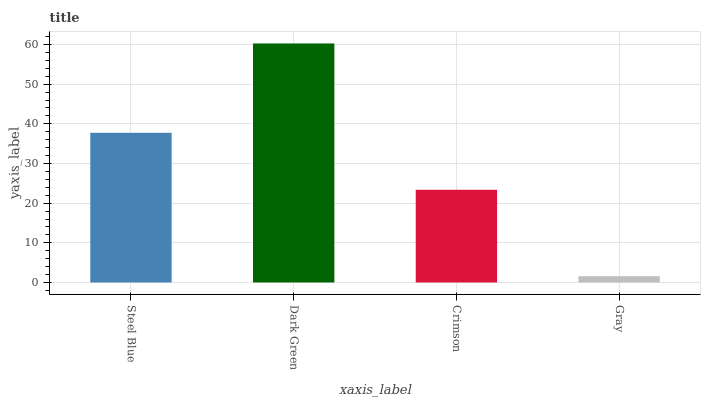Is Crimson the minimum?
Answer yes or no. No. Is Crimson the maximum?
Answer yes or no. No. Is Dark Green greater than Crimson?
Answer yes or no. Yes. Is Crimson less than Dark Green?
Answer yes or no. Yes. Is Crimson greater than Dark Green?
Answer yes or no. No. Is Dark Green less than Crimson?
Answer yes or no. No. Is Steel Blue the high median?
Answer yes or no. Yes. Is Crimson the low median?
Answer yes or no. Yes. Is Dark Green the high median?
Answer yes or no. No. Is Steel Blue the low median?
Answer yes or no. No. 